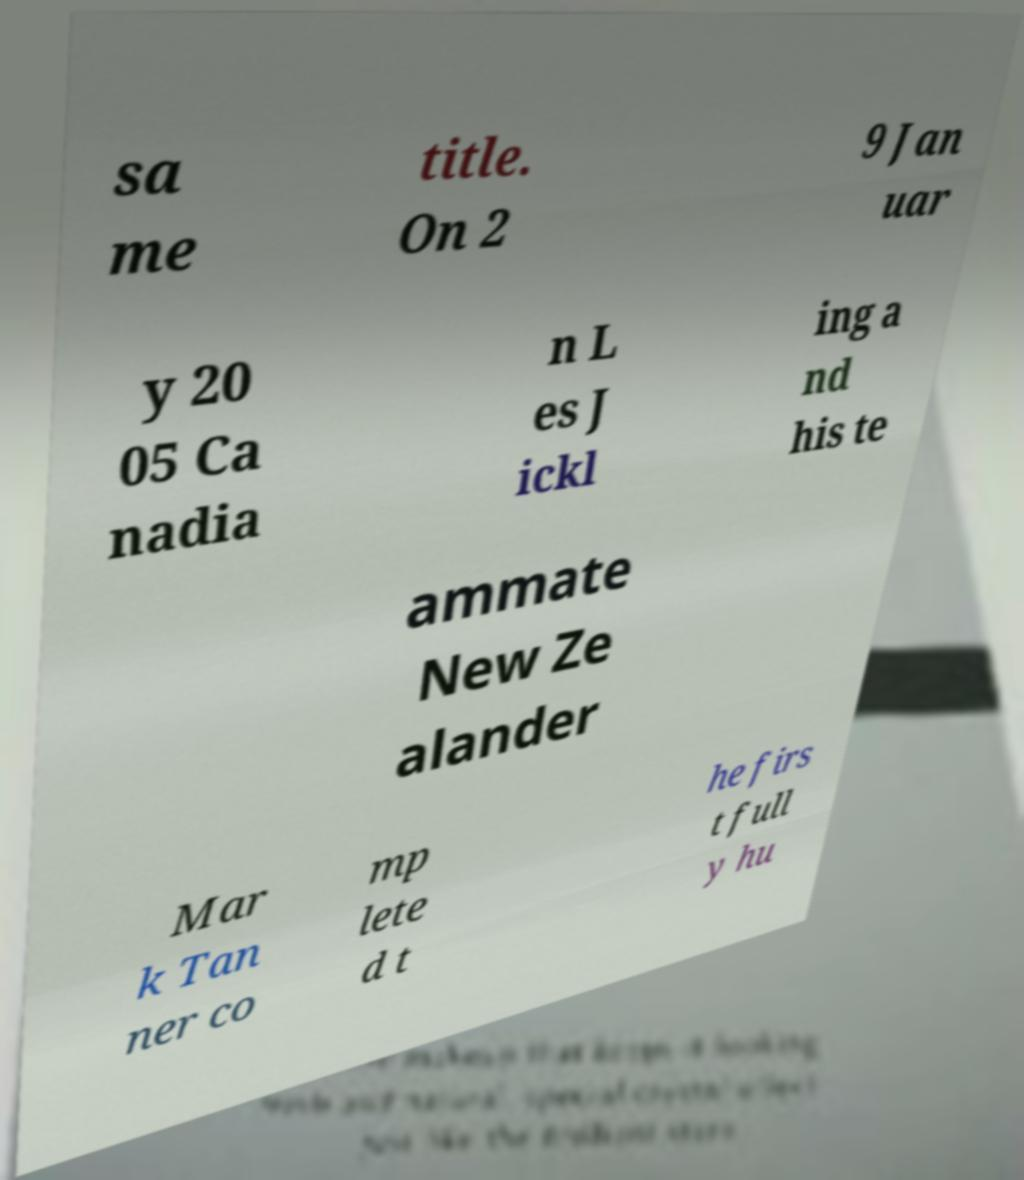Could you assist in decoding the text presented in this image and type it out clearly? sa me title. On 2 9 Jan uar y 20 05 Ca nadia n L es J ickl ing a nd his te ammate New Ze alander Mar k Tan ner co mp lete d t he firs t full y hu 